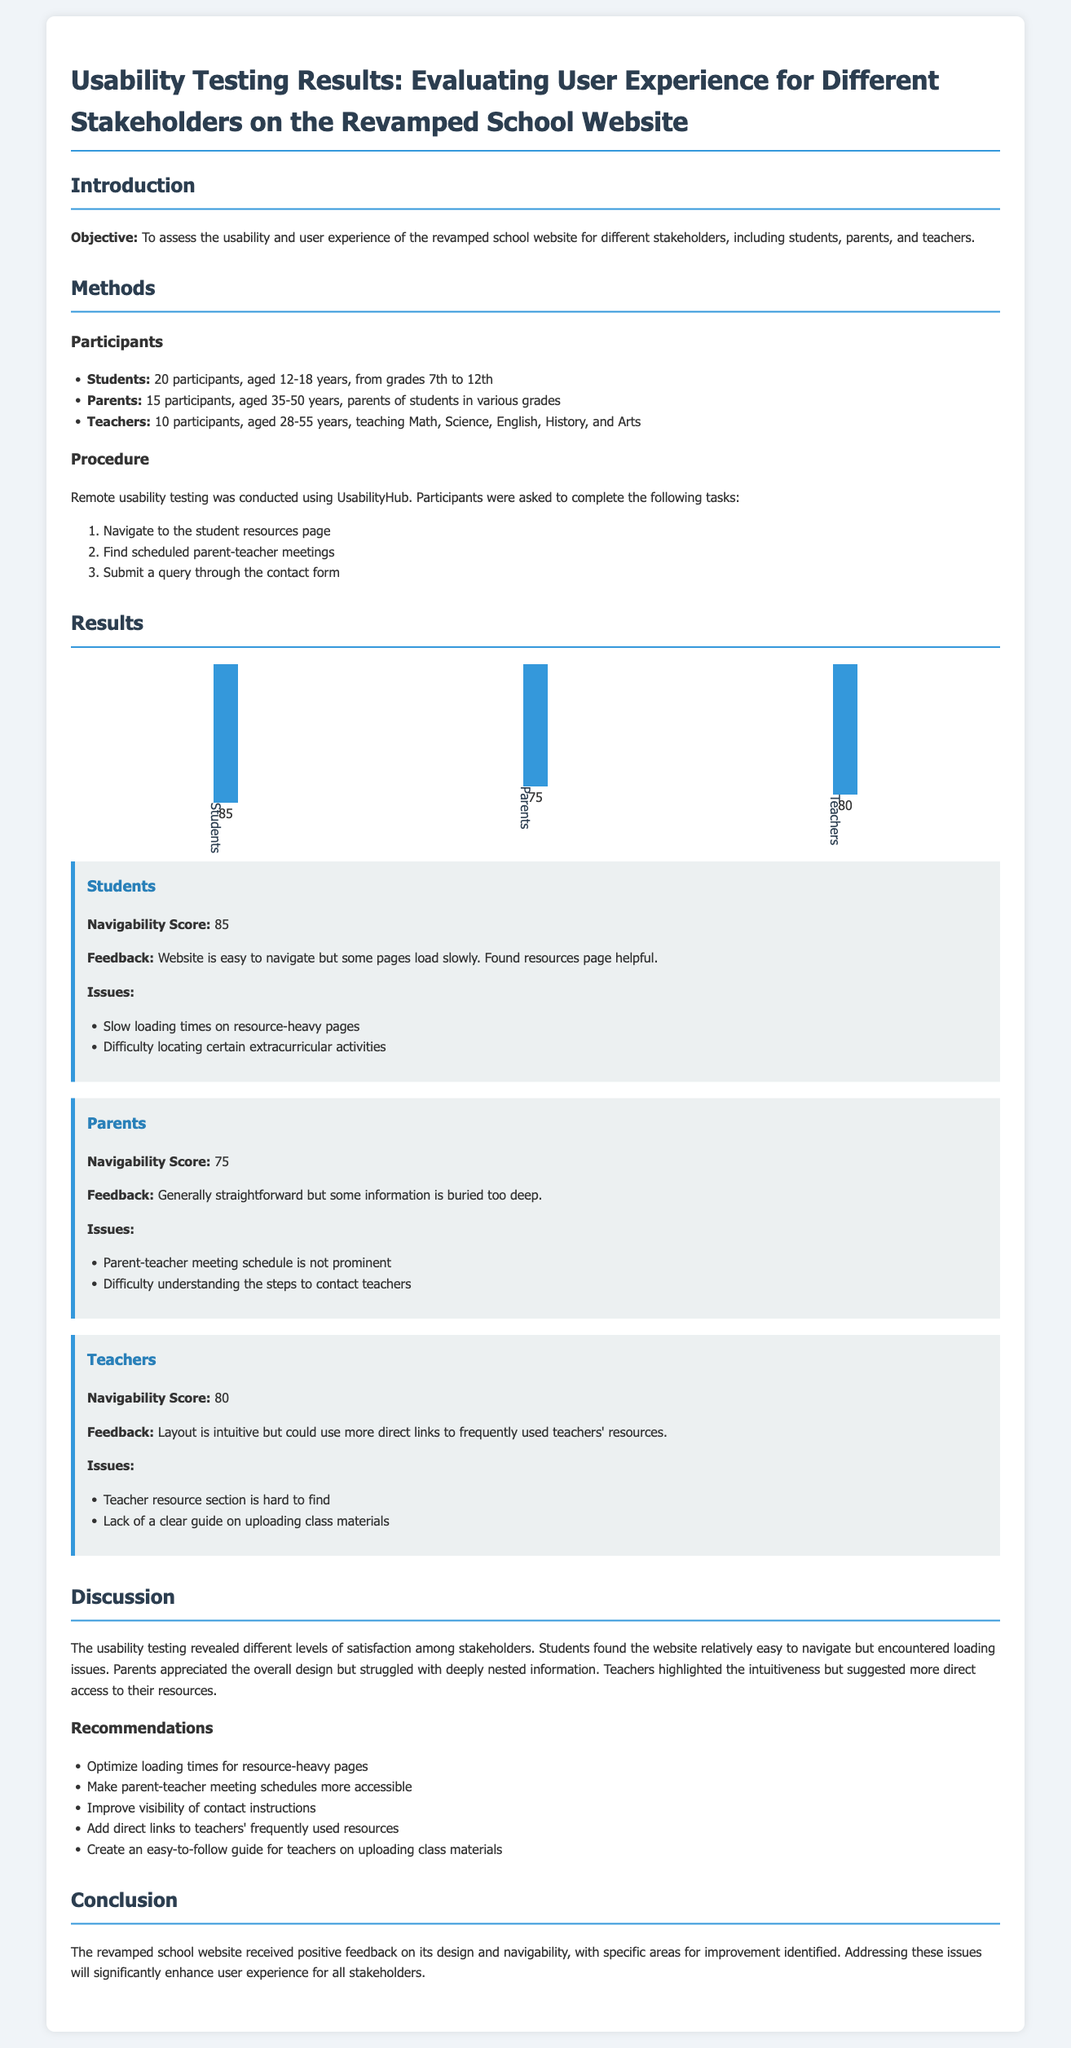what was the objective of the usability testing? The objective is to assess the usability and user experience of the revamped school website for different stakeholders.
Answer: assess usability and user experience how many participants were involved in the testing for parents? There were 15 participants involved in the usability testing for parents.
Answer: 15 what was the navigability score for students? The navigability score for students was 85.
Answer: 85 which stakeholder found the website easy to navigate but experienced slow loading times? Students found the website easy to navigate but experienced slow loading times.
Answer: Students what recommendations were made for improving the website? The recommendations included optimizing loading times and making schedules more accessible.
Answer: optimize loading times, make schedules more accessible how many teachers participated in the usability testing? 10 teachers participated in the usability testing.
Answer: 10 what was a specific issue reported by parents regarding the website? Parents reported that the parent-teacher meeting schedule is not prominent.
Answer: parent-teacher meeting schedule is not prominent what feedback did teachers provide about the website layout? Teachers stated that the layout is intuitive but could use more direct links.
Answer: intuitive but could use more direct links what was the navigability score for parents? The navigability score for parents was 75.
Answer: 75 